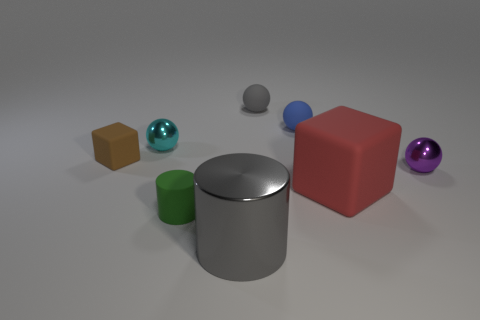What is the size of the cube that is the same material as the brown thing?
Your answer should be compact. Large. How big is the purple object?
Ensure brevity in your answer.  Small. What material is the tiny purple ball?
Your answer should be compact. Metal. Does the gray object that is in front of the red rubber object have the same size as the big red rubber object?
Provide a short and direct response. Yes. How many objects are either purple rubber cylinders or small blue balls?
Offer a very short reply. 1. What shape is the small thing that is the same color as the big shiny object?
Offer a terse response. Sphere. What is the size of the shiny thing that is right of the small cyan metallic sphere and on the left side of the large red matte cube?
Keep it short and to the point. Large. How many cyan shiny balls are there?
Keep it short and to the point. 1. What number of cubes are either green matte objects or gray matte things?
Make the answer very short. 0. There is a gray thing behind the big object that is on the left side of the big red matte object; how many big objects are left of it?
Your answer should be very brief. 1. 